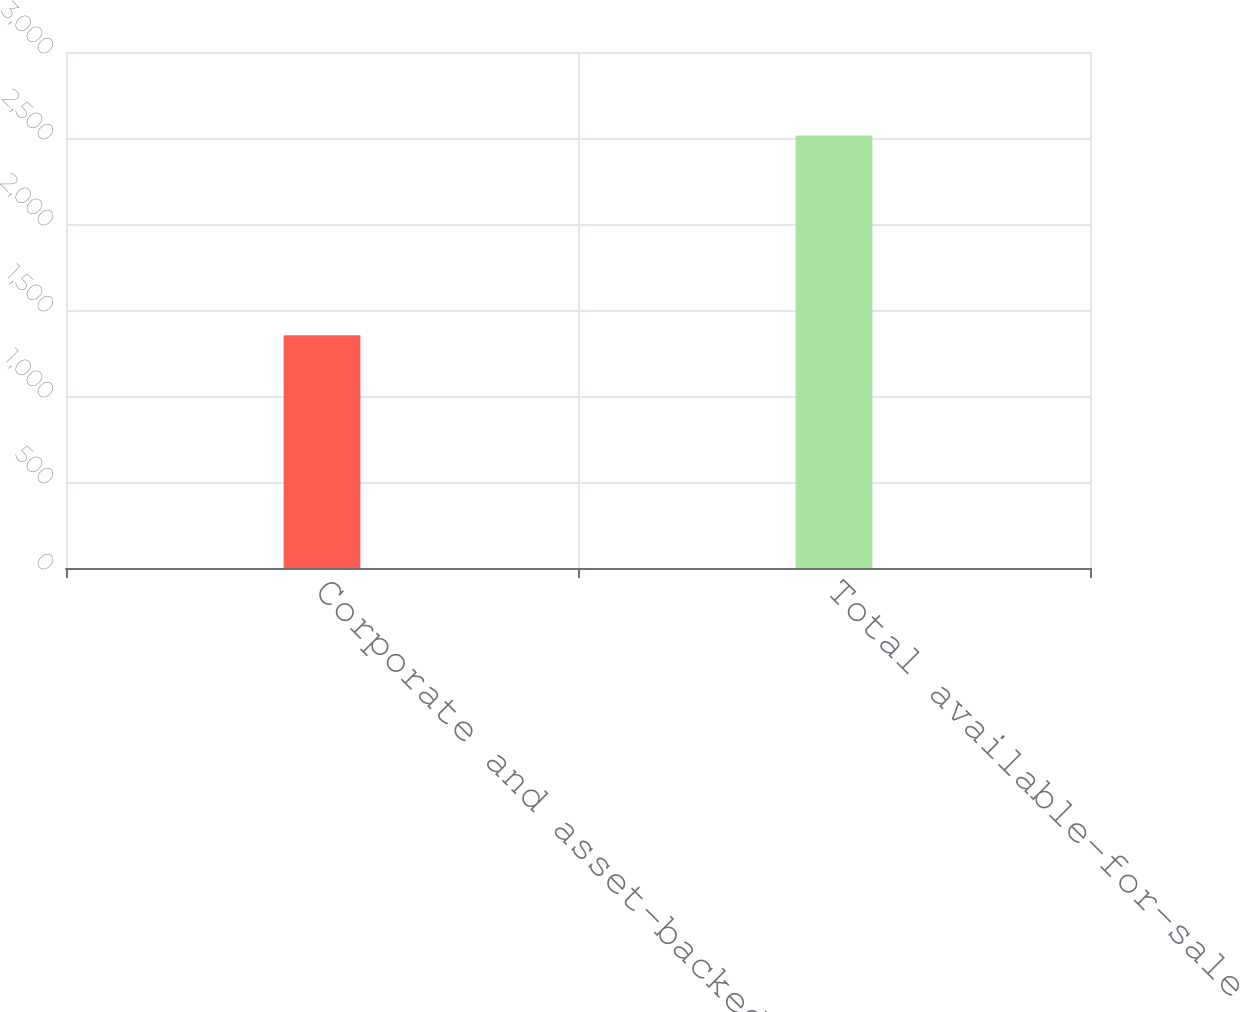Convert chart. <chart><loc_0><loc_0><loc_500><loc_500><bar_chart><fcel>Corporate and asset-backed<fcel>Total available-for-sale<nl><fcel>1353<fcel>2515<nl></chart> 